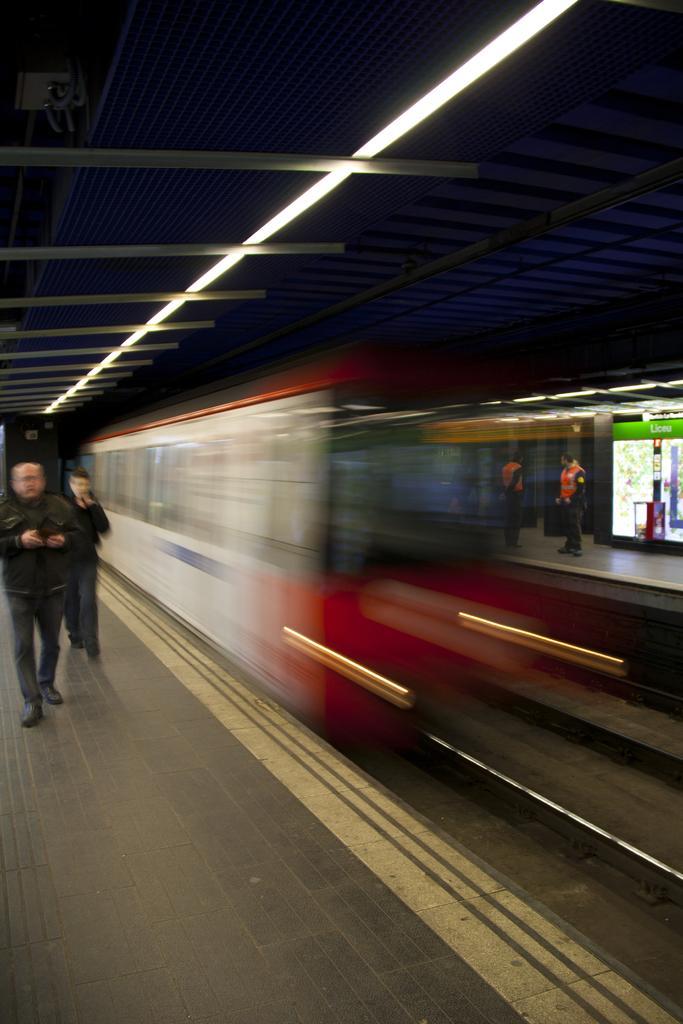Can you describe this image briefly? In this image there are a few people walking and standing on the platform, in the middle of the platform, there is a train passing on the track, at the top of the image there is a rooftop with lights. 